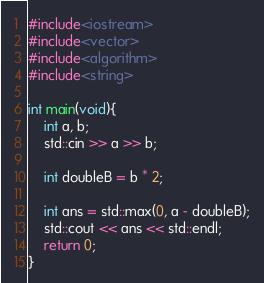<code> <loc_0><loc_0><loc_500><loc_500><_C++_>#include<iostream>
#include<vector>
#include<algorithm>
#include<string>

int main(void){
    int a, b;
    std::cin >> a >> b;

    int doubleB = b * 2;

    int ans = std::max(0, a - doubleB);
    std::cout << ans << std::endl;
    return 0;
}</code> 